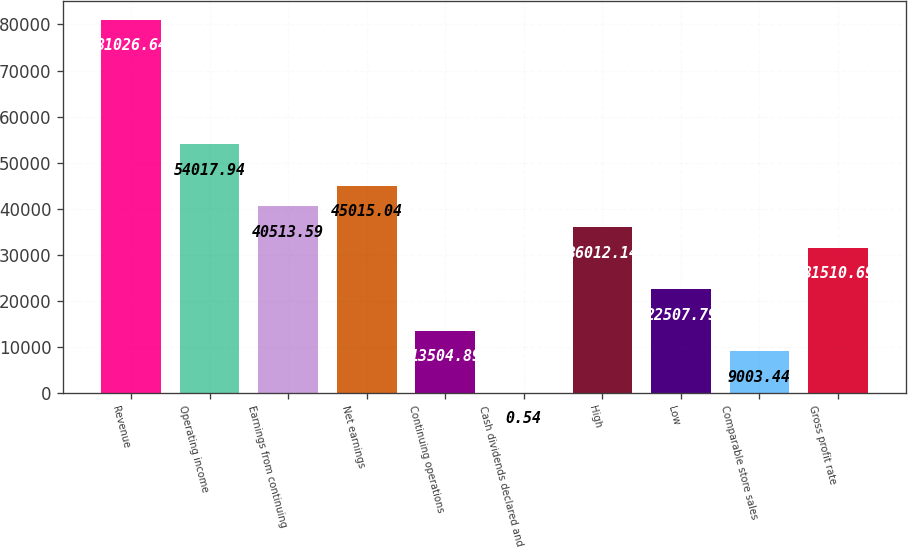Convert chart to OTSL. <chart><loc_0><loc_0><loc_500><loc_500><bar_chart><fcel>Revenue<fcel>Operating income<fcel>Earnings from continuing<fcel>Net earnings<fcel>Continuing operations<fcel>Cash dividends declared and<fcel>High<fcel>Low<fcel>Comparable store sales<fcel>Gross profit rate<nl><fcel>81026.6<fcel>54017.9<fcel>40513.6<fcel>45015<fcel>13504.9<fcel>0.54<fcel>36012.1<fcel>22507.8<fcel>9003.44<fcel>31510.7<nl></chart> 